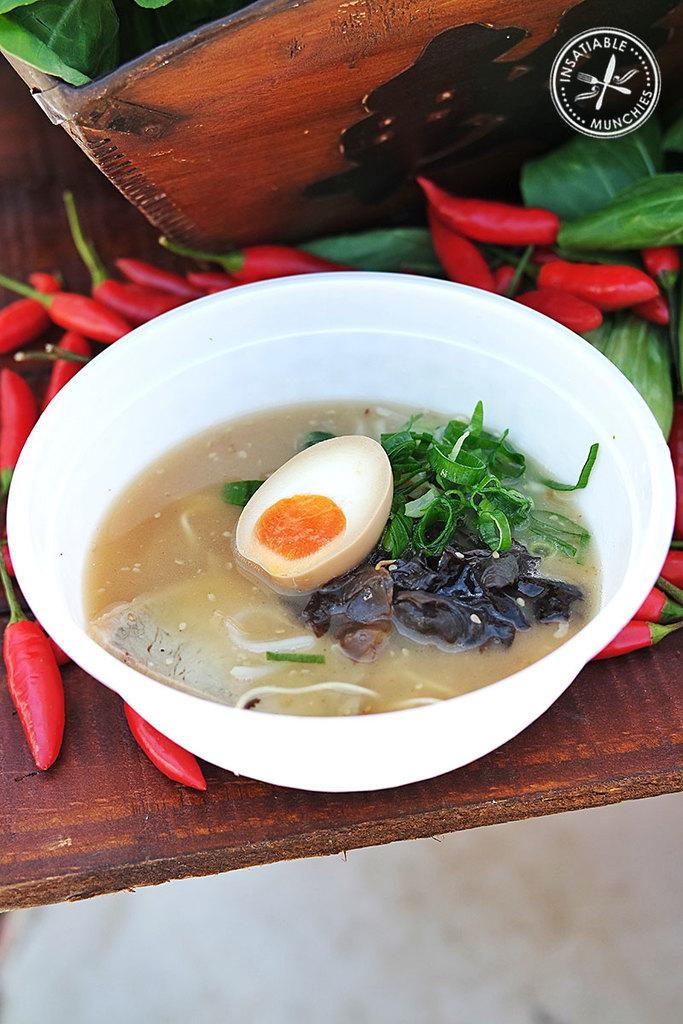What color is the bowl containing food in the image? The bowl containing food is white-colored. What type of food is in the bowl? The facts do not specify the type of food in the bowl. What other items can be seen in the image? Red chilies and green-colored leaves are visible in the image. What is the color of the table in the image? The table in the image is brown-colored. How many boots are present in the image? There are no boots present in the image. What type of brothers are depicted in the image? There are no brothers depicted in the image. 